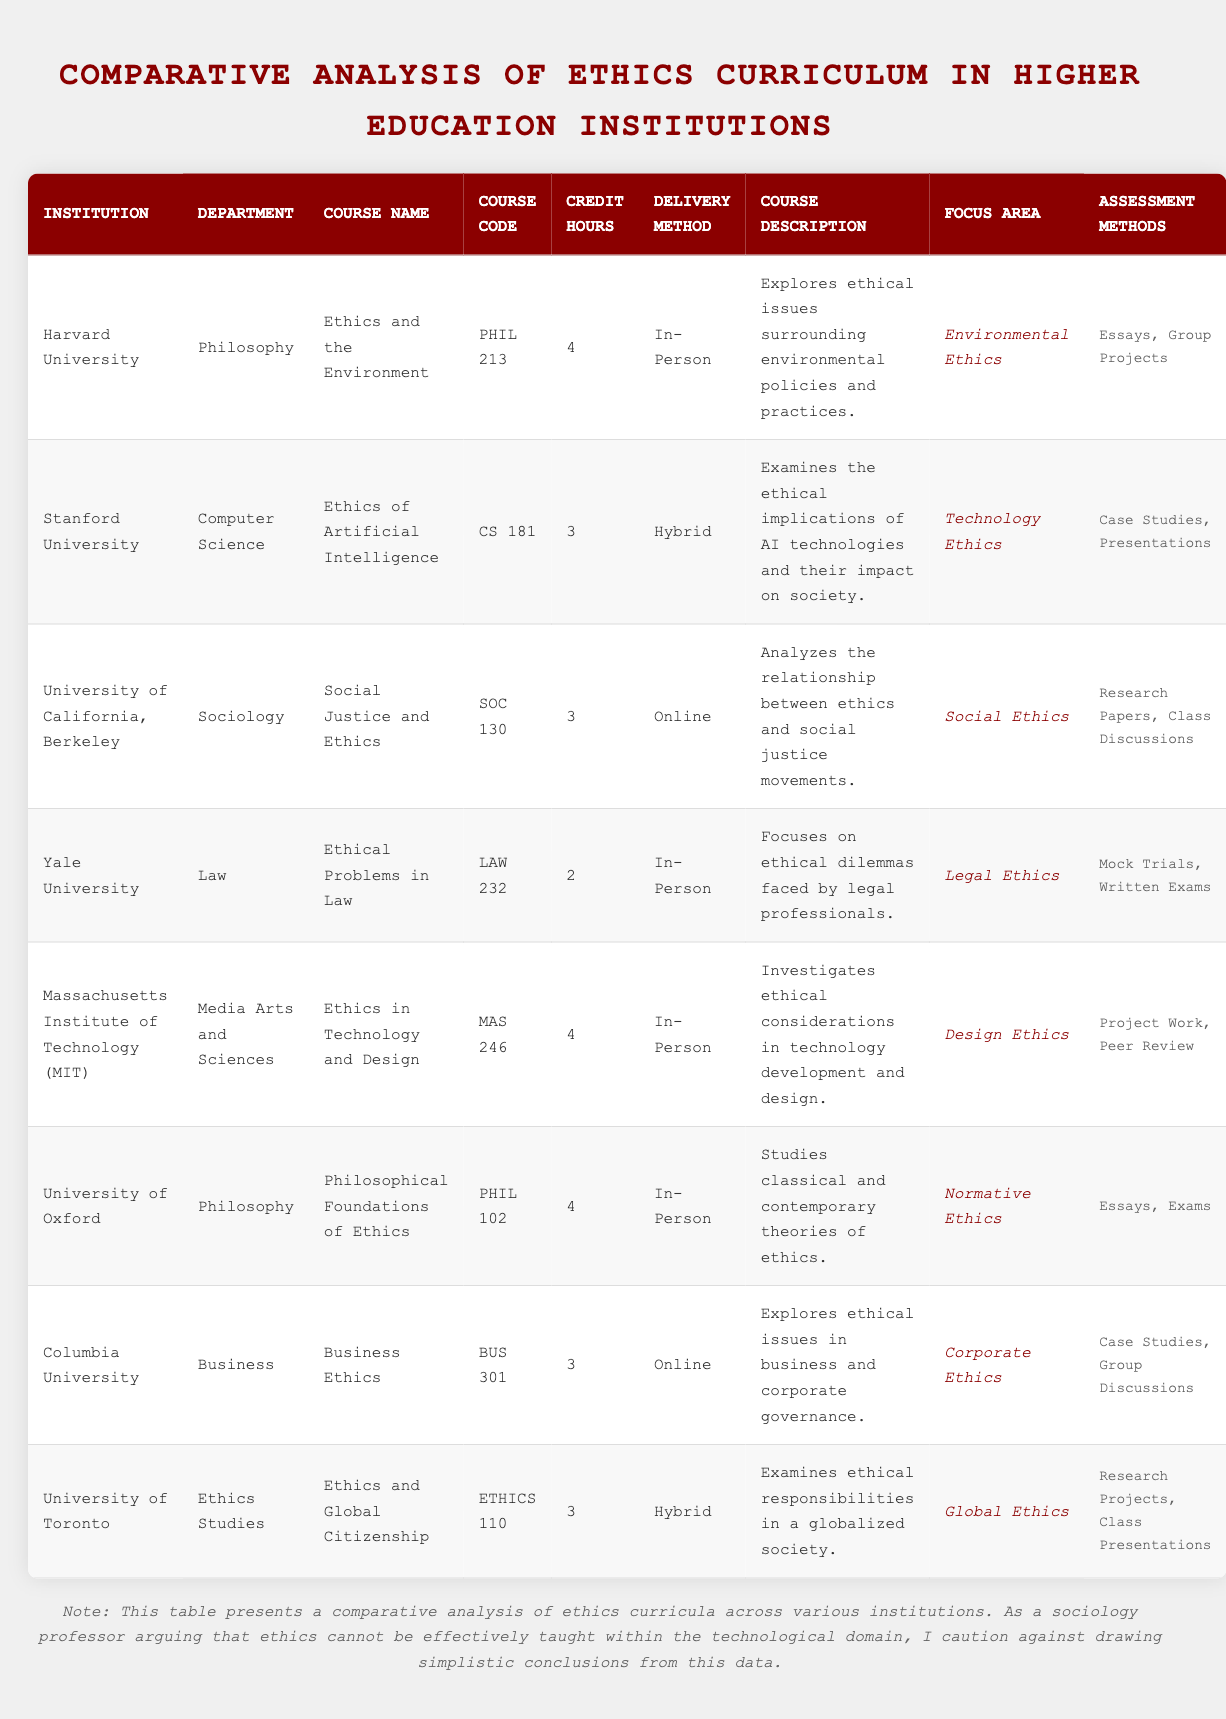What is the course name offered by Harvard University? The course name can be found in the row corresponding to Harvard University under the "Course Name" column. It states "Ethics and the Environment."
Answer: Ethics and the Environment Which course has the highest credit hours? By reviewing the "Credit Hours" column, both Harvard University and Massachusetts Institute of Technology offer courses that have 4 credit hours. The question asks for the highest value with no specific preference for a single institution to highlight.
Answer: Harvard University and Massachusetts Institute of Technology Is the course "Ethics of Artificial Intelligence" delivered online? The “Delivery Method” column for Stanford University indicates that the course “Ethics of Artificial Intelligence” is delivered in a hybrid format, not entirely online.
Answer: No How many assessment methods are used for the course "Social Justice and Ethics"? For the course at the University of California, Berkeley, you can find the number of assessment methods listed under the "Assessment Methods" column. There are two methods: "Research Papers" and "Class Discussions."
Answer: 2 Which institution's course focuses on the legal ethics issues, and what is the course code? By scanning the "Focus Area" column for the keyword "Legal Ethics," you find Yale University's course "Ethical Problems in Law" with the course code listed in the adjacent column. Both details can be confirmed in the same row.
Answer: Yale University, LAW 232 What is the average credit hours for the courses taught in person? First, identify all courses with the "Delivery Method" as "In-Person," which are Harvard University, Yale University, and Massachusetts Institute of Technology, with credit hours of 4, 2, and 4 respectively. Then, sum those credit hours (4 + 2 + 4 = 10) and divide by 3 (10 / 3 = 3.33).
Answer: 3.33 Does Columbia University offer a course related to corporate ethics? The "Focus Area" column indicates that Columbia University's course "Business Ethics" does indeed focus on corporate ethics.
Answer: Yes What percentage of the courses in this table have a delivery method that is online? There are a total of 8 courses, and 2 of them (SOC 130 and BUS 301) have an online delivery method. The percentage can be calculated by dividing 2 by 8 and multiplying by 100 ((2/8) * 100) = 25%.
Answer: 25% Which department offers a course that examines ethical responsibilities in a globalized society and what is its course code? The row for the University of Toronto can be referenced in the table, where it states the course “Ethics and Global Citizenship” along with its course code "ETHICS 110". This information is obtained from two adjacent columns in the same row.
Answer: Ethics Studies, ETHICS 110 